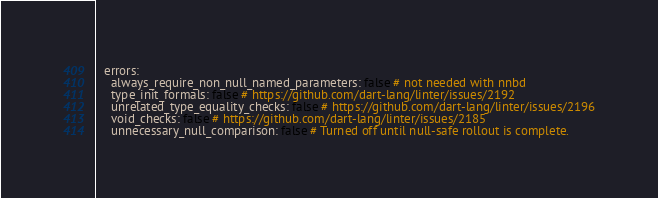<code> <loc_0><loc_0><loc_500><loc_500><_YAML_>  errors:
    always_require_non_null_named_parameters: false # not needed with nnbd
    type_init_formals: false # https://github.com/dart-lang/linter/issues/2192
    unrelated_type_equality_checks: false # https://github.com/dart-lang/linter/issues/2196
    void_checks: false # https://github.com/dart-lang/linter/issues/2185
    unnecessary_null_comparison: false # Turned off until null-safe rollout is complete.
</code> 